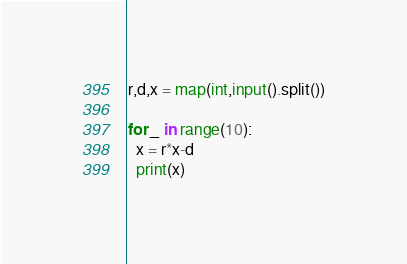<code> <loc_0><loc_0><loc_500><loc_500><_Python_>r,d,x = map(int,input().split())

for _ in range(10):
  x = r*x-d
  print(x)</code> 